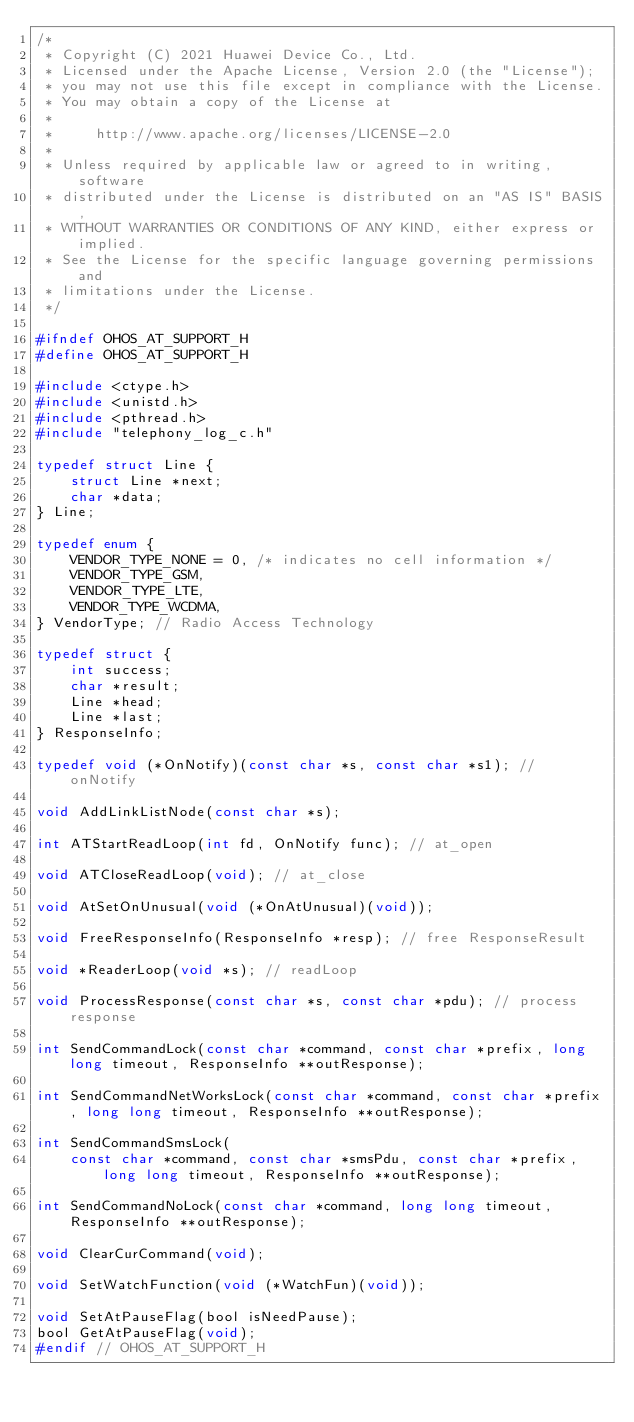<code> <loc_0><loc_0><loc_500><loc_500><_C_>/*
 * Copyright (C) 2021 Huawei Device Co., Ltd.
 * Licensed under the Apache License, Version 2.0 (the "License");
 * you may not use this file except in compliance with the License.
 * You may obtain a copy of the License at
 *
 *     http://www.apache.org/licenses/LICENSE-2.0
 *
 * Unless required by applicable law or agreed to in writing, software
 * distributed under the License is distributed on an "AS IS" BASIS,
 * WITHOUT WARRANTIES OR CONDITIONS OF ANY KIND, either express or implied.
 * See the License for the specific language governing permissions and
 * limitations under the License.
 */

#ifndef OHOS_AT_SUPPORT_H
#define OHOS_AT_SUPPORT_H

#include <ctype.h>
#include <unistd.h>
#include <pthread.h>
#include "telephony_log_c.h"

typedef struct Line {
    struct Line *next;
    char *data;
} Line;

typedef enum {
    VENDOR_TYPE_NONE = 0, /* indicates no cell information */
    VENDOR_TYPE_GSM,
    VENDOR_TYPE_LTE,
    VENDOR_TYPE_WCDMA,
} VendorType; // Radio Access Technology

typedef struct {
    int success;
    char *result;
    Line *head;
    Line *last;
} ResponseInfo;

typedef void (*OnNotify)(const char *s, const char *s1); // onNotify

void AddLinkListNode(const char *s);

int ATStartReadLoop(int fd, OnNotify func); // at_open

void ATCloseReadLoop(void); // at_close

void AtSetOnUnusual(void (*OnAtUnusual)(void));

void FreeResponseInfo(ResponseInfo *resp); // free ResponseResult

void *ReaderLoop(void *s); // readLoop

void ProcessResponse(const char *s, const char *pdu); // process response

int SendCommandLock(const char *command, const char *prefix, long long timeout, ResponseInfo **outResponse);

int SendCommandNetWorksLock(const char *command, const char *prefix, long long timeout, ResponseInfo **outResponse);

int SendCommandSmsLock(
    const char *command, const char *smsPdu, const char *prefix, long long timeout, ResponseInfo **outResponse);

int SendCommandNoLock(const char *command, long long timeout, ResponseInfo **outResponse);

void ClearCurCommand(void);

void SetWatchFunction(void (*WatchFun)(void));

void SetAtPauseFlag(bool isNeedPause);
bool GetAtPauseFlag(void);
#endif // OHOS_AT_SUPPORT_H
</code> 